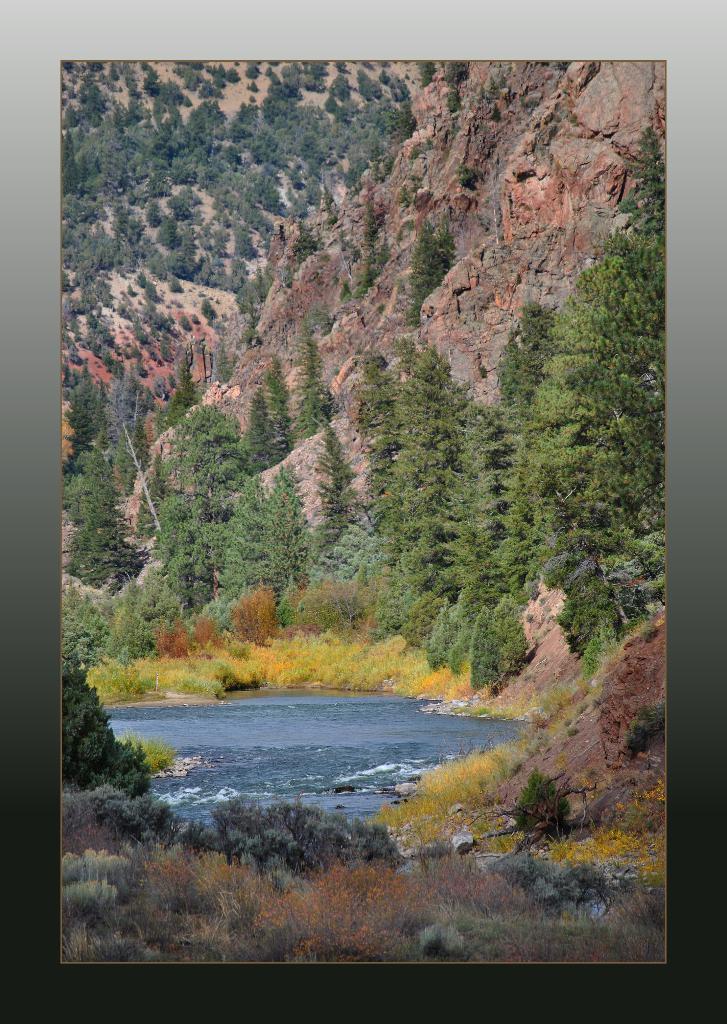Can you describe this image briefly? In this image there is a photograph, there are mountains towards the top of the image, there are trees on the mountain, there is water, there are plants towards the bottom of the image. 